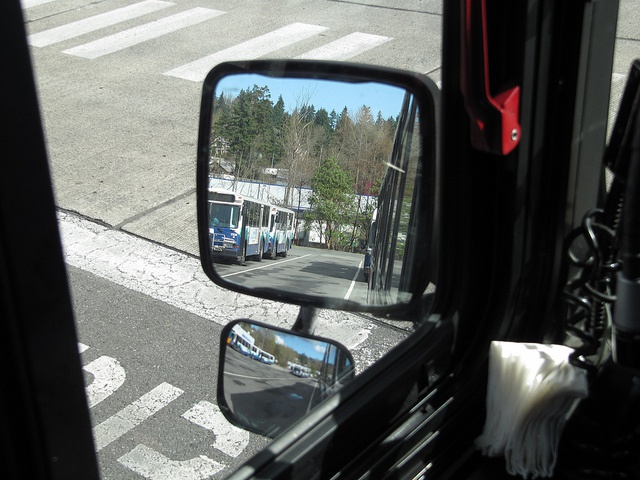Describe the objects in this image and their specific colors. I can see bus in black, gray, lightgray, darkgray, and blue tones in this image. 